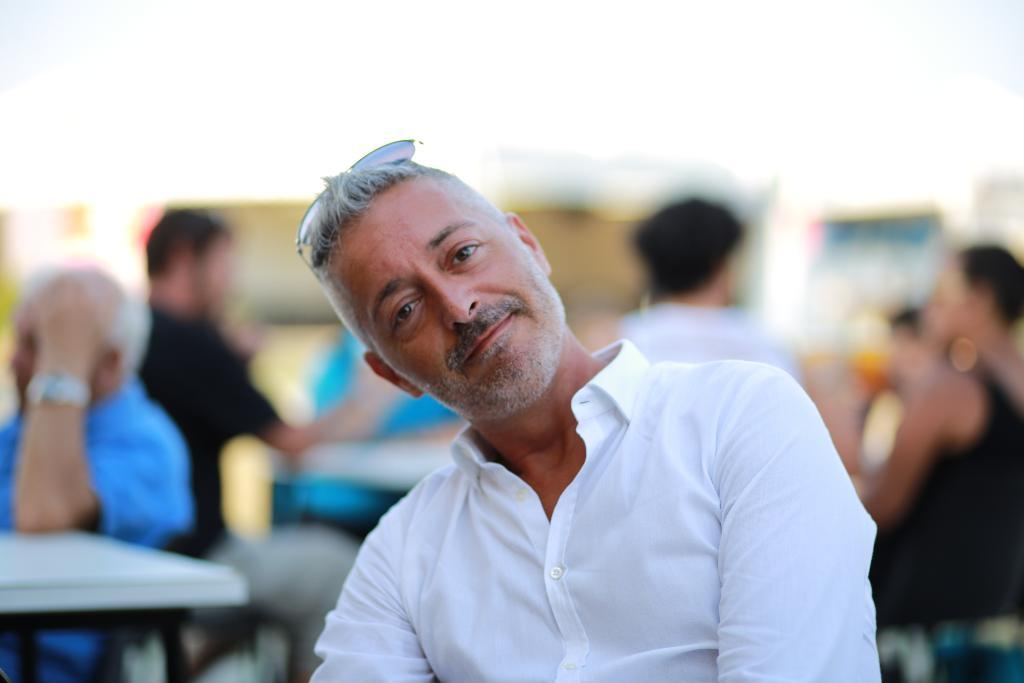What are the people in the image doing? The people in the image are sitting on chairs. What furniture is present in the image besides the chairs? There are tables in the image. What can be seen on the surface of the tables? There are objects on the surface of the tables in the image. What color are the toes of the people in the image? There is no mention of toes in the image, as the people are sitting on chairs and their feet are not visible. 